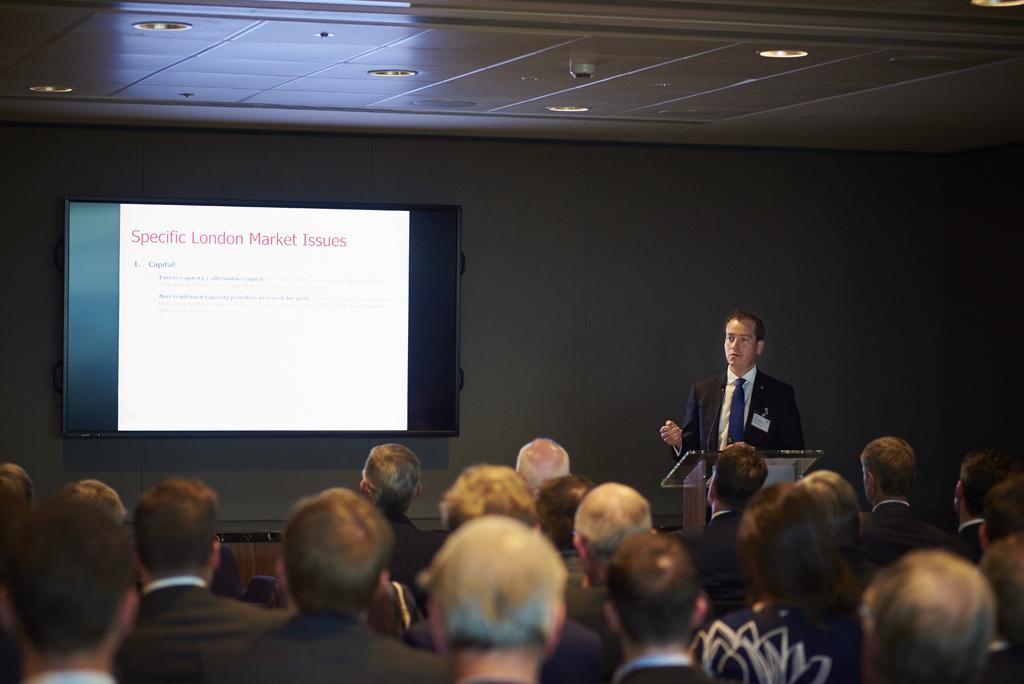What are the people in the image doing? The people in the image are sitting. What is the man in the image doing? The man in the image is standing. What is in front of the standing man? There is a podium in front of the standing man. What can be seen in the background of the image? There is a wall and a screen in the background of the image. What is visible at the top of the image? There are lights visible at the top of the image. How far away is the station from the image? There is no station present in the image, so it cannot be determined how far away it is. Is there a cellar visible in the image? No, there is no cellar present in the image. 